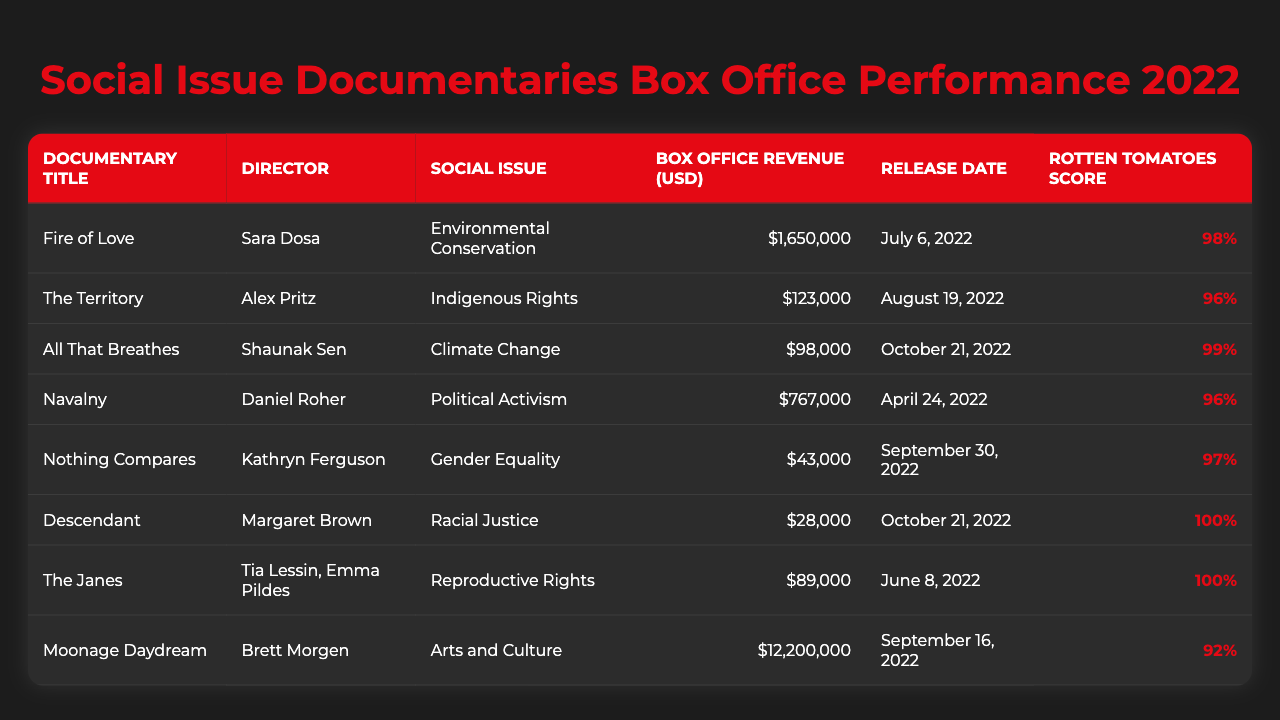What is the box office revenue for "Fire of Love"? The table lists "Fire of Love" with a box office revenue of $1,650,000.
Answer: $1,650,000 Which documentary has the highest Rotten Tomatoes score? The documentary "Descendant" has a Rotten Tomatoes score of 100%, which is the highest in the table.
Answer: Descendant How much total box office revenue was made by documentaries that focus on gender equality and reproductive rights? The box office revenues for "Nothing Compares" (gender equality) is $43,000 and "The Janes" (reproductive rights) is $89,000. Adding these gives $43,000 + $89,000 = $132,000.
Answer: $132,000 Which social issue has the documentary "The Territory" focused on? The table indicates that "The Territory" focuses on Indigenous Rights.
Answer: Indigenous Rights Is the box office revenue for "Moonage Daydream" greater than that of "Navalny"? "Moonage Daydream" has a box office revenue of $12,200,000 and "Navalny" has $767,000. Since $12,200,000 is greater than $767,000, the statement is true.
Answer: Yes What is the average box office revenue of the documentaries listed? The sum of all the box office revenues is $1,650,000 + $123,000 + $98,000 + $767,000 + $43,000 + $28,000 + $89,000 + $12,200,000 = $14,798,000. There are 8 documentaries, so the average is $14,798,000 / 8 = $1,849,750.
Answer: $1,849,750 Which documentary had the lowest box office revenue, and what was that revenue? The table shows "Descendant" has the lowest box office revenue of $28,000.
Answer: Descendant, $28,000 How many documentaries in the table received a Rotten Tomatoes score of 96% or higher? The documentaries "Fire of Love," "The Territory," "All That Breathes," "Navalny," "Nothing Compares," "The Janes," and "Descendant" have scores of 96% or higher. This counts to a total of 7 documentaries.
Answer: 7 Does "All That Breathes" focus on climate change? The table states that "All That Breathes" indeed focuses on Climate Change, confirming the statement's truth.
Answer: Yes Which documentary directed by Sara Dosa focuses on environmental conservation? The table indicates that "Fire of Love," directed by Sara Dosa, focuses on Environmental Conservation.
Answer: Fire of Love 